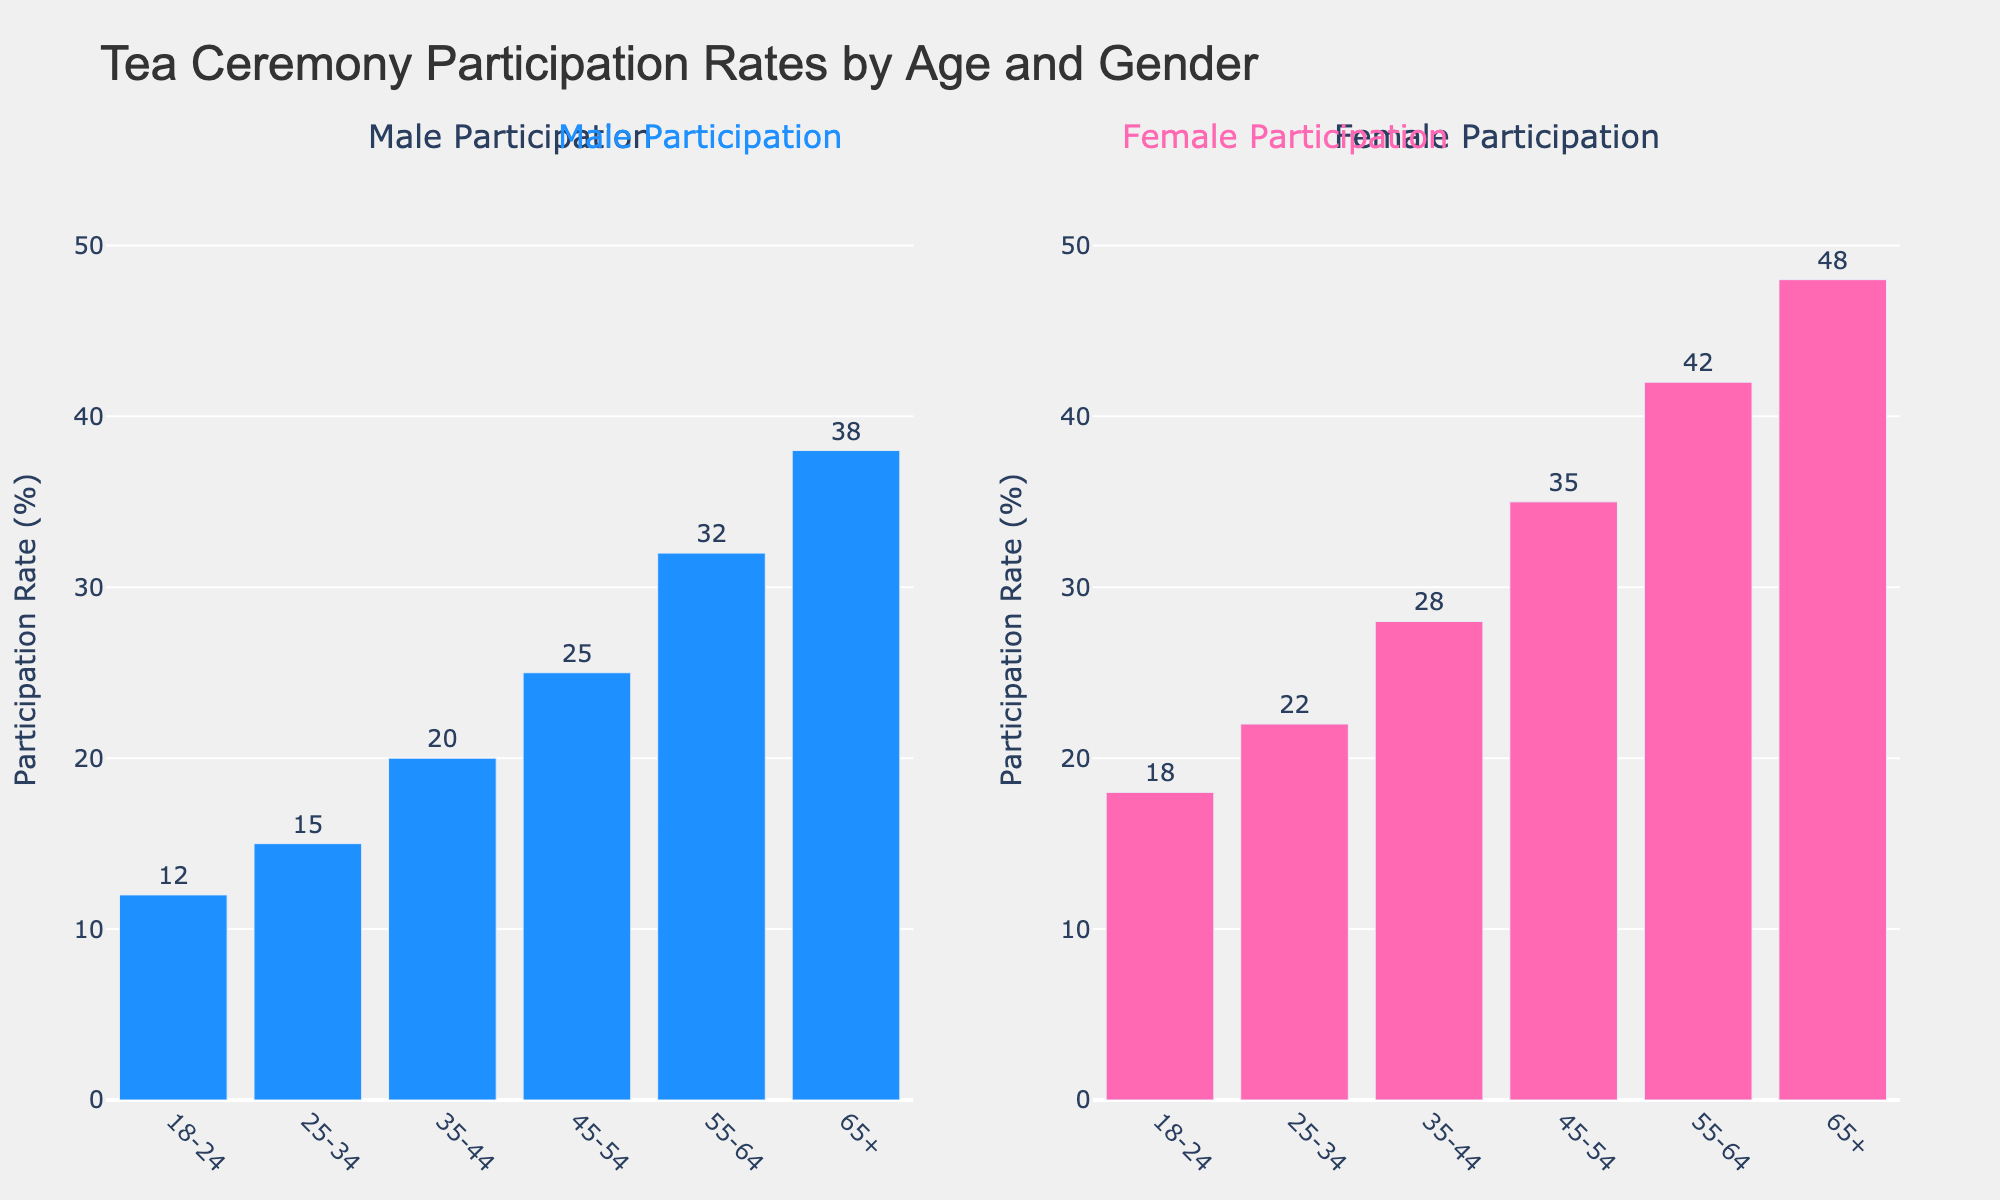How does the participation rate of males aged 18-24 compare to those aged 65+? The figure shows that male participation rates are 12% for the age group 18-24 and 38% for the age group 65+. Subtract 12 from 38 to find the difference, which is 26%.
Answer: 26% Which age group has the highest participation rate for females? From the figure, the highest bar in the female participation subplot corresponds to the age group 65+, with a participation rate of 48%.
Answer: 65+ Compare the participation rate of males and females in the 25-34 age group. In the 25-34 age group, male participation is 15%, while female participation is 22%. The female participation rate exceeds the male rate by 7%.
Answer: 7% What is the participation rate gap between males and females in the 55-64 age group? The figure shows male participation at 32% and female participation at 42% in the 55-64 age group. The gap is calculated as 42% - 32% = 10%.
Answer: 10% What is the average participation rate for males across all age groups? Participation rates for males: 12%, 15%, 20%, 25%, 32%, 38%. Sum these and divide by the number of groups: (12 + 15 + 20 + 25 + 32 + 38) / 6 = 142 / 6 ≈ 23.67%.
Answer: 23.67% Which age group shows the smallest difference in participation rates between males and females? Examine the differences: 18-24 (6%), 25-34 (7%), 35-44 (8%), 45-54 (10%), 55-64 (10%), 65+ (10%). The smallest difference is in the 18-24 age group, at 6%.
Answer: 18-24 How many age groups have a higher female participation rate than male rate by more than 10%? Calculate the differences for each age group: 18-24 (6%), 25-34 (7%), 35-44 (8%), 45-54 (10%), 55-64 (10%), 65+ (10%). No age group exceeds a 10% difference.
Answer: 0 What is the total participation rate for females in the 18-24 and 25-34 age groups combined? Female rates for 18-24 is 18% and for 25-34 is 22%. Summing these, 18 + 22 = 40%.
Answer: 40% Is the male participation rate in the age group 45-54 higher or lower than the female participation rate in the 25-34 age group? The male participation rate for 45-54 is 25%, while the female rate for 25-34 is 22%. Therefore, 25% is higher than 22%.
Answer: Higher 